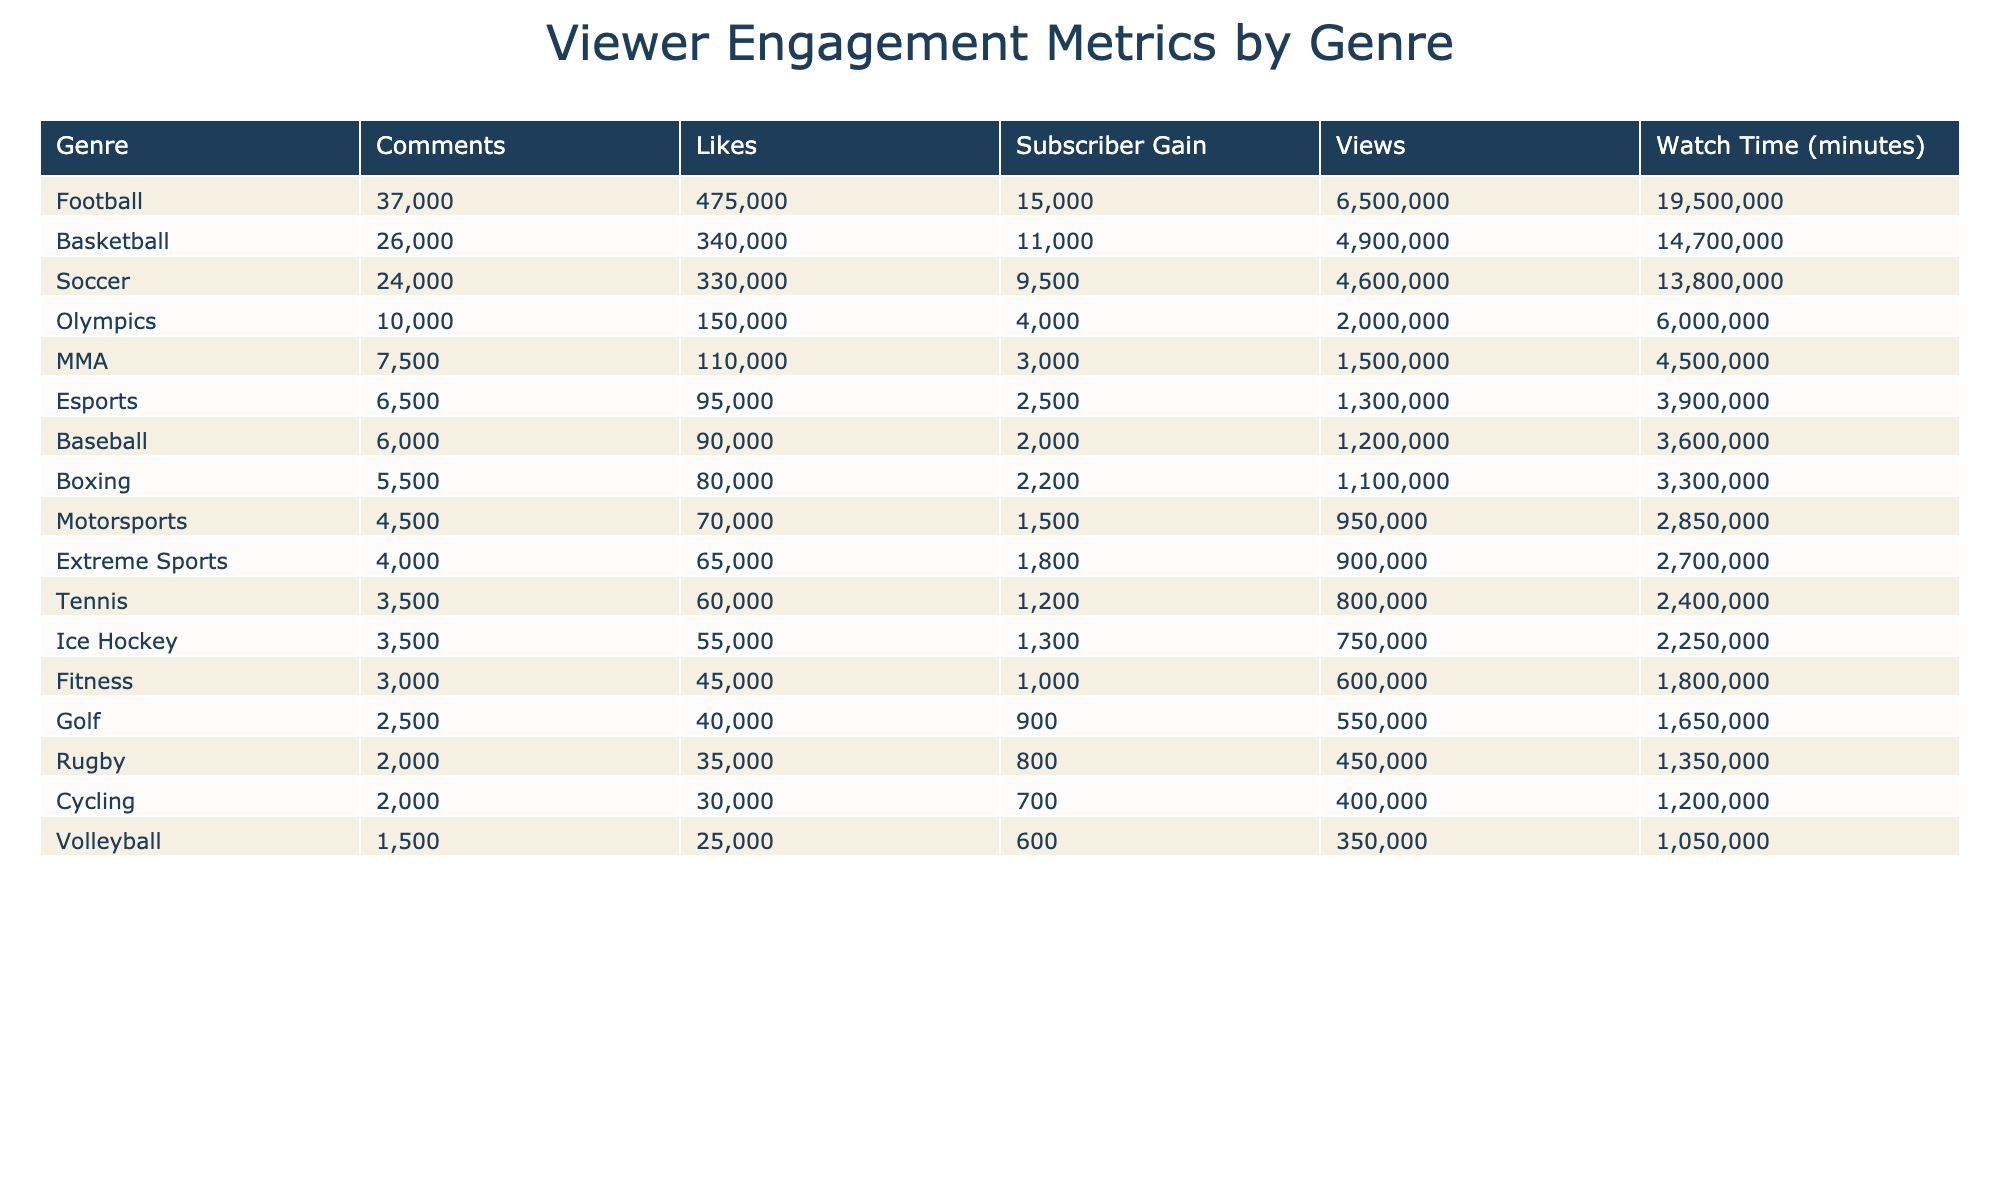What genre received the highest number of views? The genre with the highest number of views can be found in the Views column of the table. Looking at the data, "Football" has the highest total views with 4,000,000 from the "Super Bowl LVII Postgame Analysis."
Answer: Football How many total likes did the Basketball genre receive? To find the total likes for the Basketball genre, we add the likes from all Basketball videos: 220,000 (NBA Finals) + 120,000 (March Madness) = 340,000.
Answer: 340,000 Is it true that the Soccer genre had more comments than the Baseball genre? We can compare the total comments from both genres: Soccer had 18,000 (NBA Finals) + 15,000 (World Cup) = 33,000 comments, while Baseball had only 6,000 comments (MLB). Since 33,000 is greater than 6,000, it is true.
Answer: Yes What is the average watch time for the Extreme Sports and MMA genres combined? First, we find the total watch time for both genres: Extreme Sports had 2,700,000 minutes and MMA had 4,500,000 minutes. Their sum is 2,700,000 + 4,500,000 = 7,200,000. There are 2 videos, so the average is 7,200,000 / 2 = 3,600,000 minutes.
Answer: 3,600,000 Which genre had the lowest subscriber gain and what was the value? By checking the Subscriber Gain column, we find that "Cycling" had the lowest subscriber gain at 700.
Answer: 700 What is the total number of comments across all genres? We add up all the comments from each genre: 12,000 + 18,000 + 9,000 + 6,000 + 4,500 + 3,500 + 10,000 + 3,000 + 7,500 + 2,000 + 25,000 + 8,000 + 15,000 + 3,500 + 3,000 + 2,500 + 1,500 + 2,000 + 5,500 + 4,000 + 6,500 = 193,000 comments total.
Answer: 193,000 How does the average likes for the Tennis genre compare with that of the Football genre? First, the average likes for Tennis is calculated: 60,000 for "Wimbledon 2023" which is the only video in its genre, making the average also 60,000. For Football, the average is (175,000 + 300,000) / 2 = 237,500. Thus, Football has more likes than Tennis.
Answer: Football has more likes Which genre has more total views, Baseball or MMA? The total views for Baseball are 1,200,000, while for MMA they are 1,500,000. Since 1,500,000 is greater than 1,200,000, MMA has more total views than Baseball.
Answer: MMA 